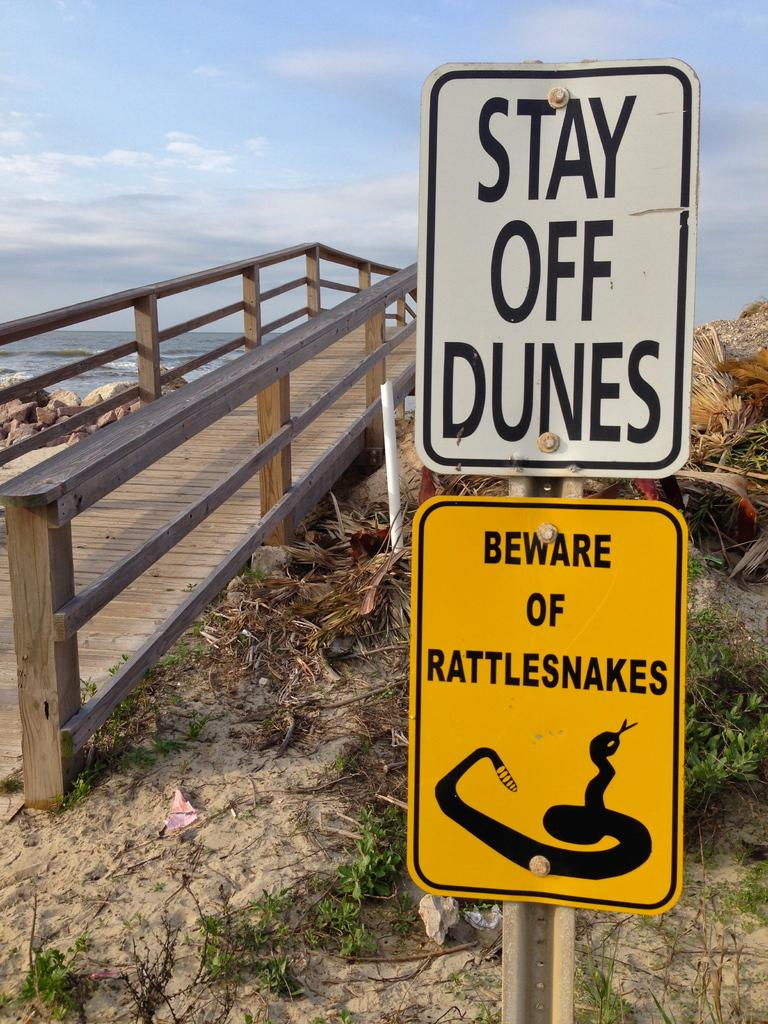<image>
Offer a succinct explanation of the picture presented. signs that warnsm of rattlesnakes on the beach 